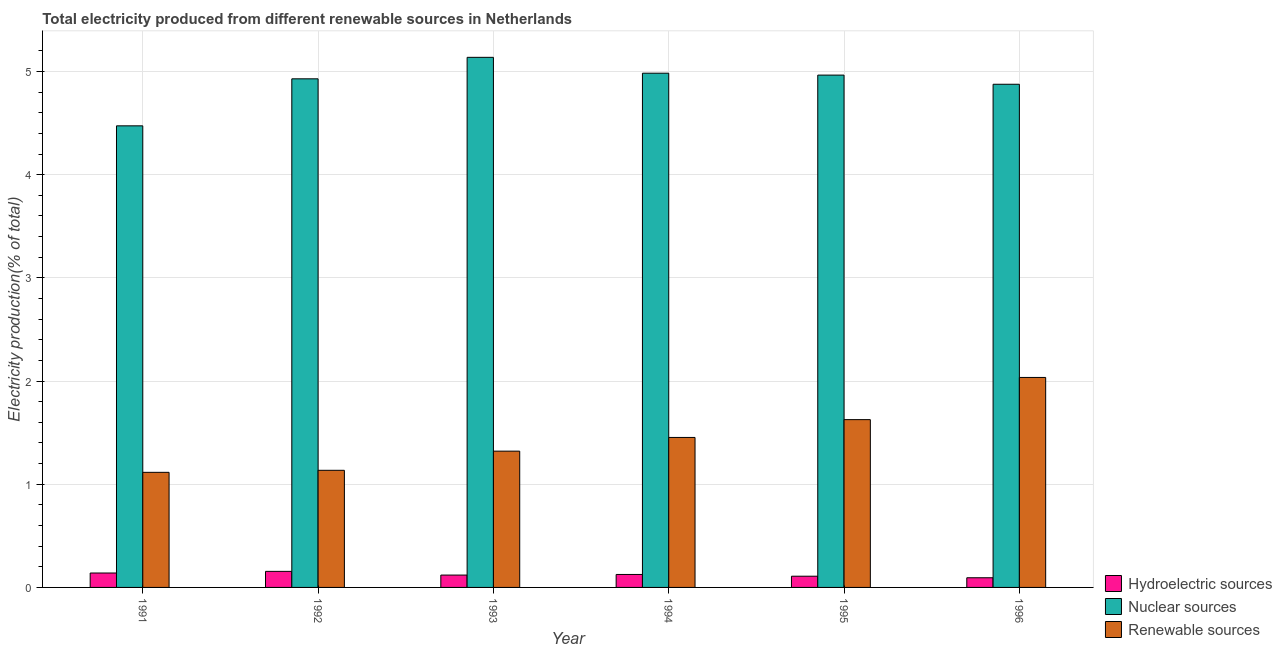How many different coloured bars are there?
Offer a terse response. 3. How many groups of bars are there?
Keep it short and to the point. 6. Are the number of bars per tick equal to the number of legend labels?
Offer a terse response. Yes. How many bars are there on the 4th tick from the left?
Ensure brevity in your answer.  3. What is the percentage of electricity produced by hydroelectric sources in 1995?
Offer a very short reply. 0.11. Across all years, what is the maximum percentage of electricity produced by hydroelectric sources?
Give a very brief answer. 0.16. Across all years, what is the minimum percentage of electricity produced by hydroelectric sources?
Your response must be concise. 0.09. In which year was the percentage of electricity produced by hydroelectric sources minimum?
Make the answer very short. 1996. What is the total percentage of electricity produced by nuclear sources in the graph?
Your response must be concise. 29.36. What is the difference between the percentage of electricity produced by nuclear sources in 1991 and that in 1993?
Provide a short and direct response. -0.66. What is the difference between the percentage of electricity produced by renewable sources in 1991 and the percentage of electricity produced by nuclear sources in 1992?
Offer a very short reply. -0.02. What is the average percentage of electricity produced by hydroelectric sources per year?
Keep it short and to the point. 0.12. What is the ratio of the percentage of electricity produced by renewable sources in 1992 to that in 1995?
Provide a succinct answer. 0.7. Is the percentage of electricity produced by nuclear sources in 1993 less than that in 1996?
Offer a terse response. No. Is the difference between the percentage of electricity produced by nuclear sources in 1994 and 1995 greater than the difference between the percentage of electricity produced by hydroelectric sources in 1994 and 1995?
Give a very brief answer. No. What is the difference between the highest and the second highest percentage of electricity produced by hydroelectric sources?
Offer a very short reply. 0.02. What is the difference between the highest and the lowest percentage of electricity produced by nuclear sources?
Offer a terse response. 0.66. What does the 3rd bar from the left in 1995 represents?
Your answer should be very brief. Renewable sources. What does the 3rd bar from the right in 1994 represents?
Your answer should be compact. Hydroelectric sources. How many bars are there?
Give a very brief answer. 18. Are all the bars in the graph horizontal?
Ensure brevity in your answer.  No. Does the graph contain any zero values?
Give a very brief answer. No. Does the graph contain grids?
Provide a short and direct response. Yes. Where does the legend appear in the graph?
Give a very brief answer. Bottom right. How many legend labels are there?
Your response must be concise. 3. What is the title of the graph?
Offer a very short reply. Total electricity produced from different renewable sources in Netherlands. What is the label or title of the X-axis?
Offer a very short reply. Year. What is the Electricity production(% of total) in Hydroelectric sources in 1991?
Offer a terse response. 0.14. What is the Electricity production(% of total) of Nuclear sources in 1991?
Ensure brevity in your answer.  4.47. What is the Electricity production(% of total) in Renewable sources in 1991?
Give a very brief answer. 1.12. What is the Electricity production(% of total) in Hydroelectric sources in 1992?
Keep it short and to the point. 0.16. What is the Electricity production(% of total) of Nuclear sources in 1992?
Keep it short and to the point. 4.93. What is the Electricity production(% of total) of Renewable sources in 1992?
Your answer should be compact. 1.13. What is the Electricity production(% of total) in Hydroelectric sources in 1993?
Keep it short and to the point. 0.12. What is the Electricity production(% of total) in Nuclear sources in 1993?
Your answer should be compact. 5.14. What is the Electricity production(% of total) in Renewable sources in 1993?
Give a very brief answer. 1.32. What is the Electricity production(% of total) of Hydroelectric sources in 1994?
Your answer should be compact. 0.13. What is the Electricity production(% of total) in Nuclear sources in 1994?
Ensure brevity in your answer.  4.98. What is the Electricity production(% of total) of Renewable sources in 1994?
Make the answer very short. 1.45. What is the Electricity production(% of total) of Hydroelectric sources in 1995?
Offer a terse response. 0.11. What is the Electricity production(% of total) of Nuclear sources in 1995?
Offer a terse response. 4.97. What is the Electricity production(% of total) of Renewable sources in 1995?
Give a very brief answer. 1.63. What is the Electricity production(% of total) in Hydroelectric sources in 1996?
Your answer should be very brief. 0.09. What is the Electricity production(% of total) in Nuclear sources in 1996?
Ensure brevity in your answer.  4.88. What is the Electricity production(% of total) in Renewable sources in 1996?
Ensure brevity in your answer.  2.03. Across all years, what is the maximum Electricity production(% of total) of Hydroelectric sources?
Provide a succinct answer. 0.16. Across all years, what is the maximum Electricity production(% of total) of Nuclear sources?
Your response must be concise. 5.14. Across all years, what is the maximum Electricity production(% of total) of Renewable sources?
Your answer should be compact. 2.03. Across all years, what is the minimum Electricity production(% of total) in Hydroelectric sources?
Provide a succinct answer. 0.09. Across all years, what is the minimum Electricity production(% of total) of Nuclear sources?
Your response must be concise. 4.47. Across all years, what is the minimum Electricity production(% of total) in Renewable sources?
Provide a succinct answer. 1.12. What is the total Electricity production(% of total) in Hydroelectric sources in the graph?
Give a very brief answer. 0.74. What is the total Electricity production(% of total) of Nuclear sources in the graph?
Provide a succinct answer. 29.36. What is the total Electricity production(% of total) of Renewable sources in the graph?
Your answer should be very brief. 8.69. What is the difference between the Electricity production(% of total) of Hydroelectric sources in 1991 and that in 1992?
Your answer should be compact. -0.02. What is the difference between the Electricity production(% of total) in Nuclear sources in 1991 and that in 1992?
Provide a short and direct response. -0.46. What is the difference between the Electricity production(% of total) in Renewable sources in 1991 and that in 1992?
Ensure brevity in your answer.  -0.02. What is the difference between the Electricity production(% of total) of Hydroelectric sources in 1991 and that in 1993?
Make the answer very short. 0.02. What is the difference between the Electricity production(% of total) of Nuclear sources in 1991 and that in 1993?
Give a very brief answer. -0.66. What is the difference between the Electricity production(% of total) in Renewable sources in 1991 and that in 1993?
Your response must be concise. -0.21. What is the difference between the Electricity production(% of total) in Hydroelectric sources in 1991 and that in 1994?
Provide a short and direct response. 0.01. What is the difference between the Electricity production(% of total) in Nuclear sources in 1991 and that in 1994?
Offer a terse response. -0.51. What is the difference between the Electricity production(% of total) of Renewable sources in 1991 and that in 1994?
Your answer should be compact. -0.34. What is the difference between the Electricity production(% of total) in Hydroelectric sources in 1991 and that in 1995?
Offer a very short reply. 0.03. What is the difference between the Electricity production(% of total) in Nuclear sources in 1991 and that in 1995?
Provide a short and direct response. -0.49. What is the difference between the Electricity production(% of total) in Renewable sources in 1991 and that in 1995?
Make the answer very short. -0.51. What is the difference between the Electricity production(% of total) of Hydroelectric sources in 1991 and that in 1996?
Your answer should be compact. 0.05. What is the difference between the Electricity production(% of total) in Nuclear sources in 1991 and that in 1996?
Provide a short and direct response. -0.4. What is the difference between the Electricity production(% of total) of Renewable sources in 1991 and that in 1996?
Provide a succinct answer. -0.92. What is the difference between the Electricity production(% of total) in Hydroelectric sources in 1992 and that in 1993?
Offer a terse response. 0.04. What is the difference between the Electricity production(% of total) of Nuclear sources in 1992 and that in 1993?
Provide a short and direct response. -0.21. What is the difference between the Electricity production(% of total) of Renewable sources in 1992 and that in 1993?
Provide a short and direct response. -0.19. What is the difference between the Electricity production(% of total) in Hydroelectric sources in 1992 and that in 1994?
Ensure brevity in your answer.  0.03. What is the difference between the Electricity production(% of total) of Nuclear sources in 1992 and that in 1994?
Your answer should be very brief. -0.05. What is the difference between the Electricity production(% of total) in Renewable sources in 1992 and that in 1994?
Provide a succinct answer. -0.32. What is the difference between the Electricity production(% of total) of Hydroelectric sources in 1992 and that in 1995?
Provide a succinct answer. 0.05. What is the difference between the Electricity production(% of total) in Nuclear sources in 1992 and that in 1995?
Provide a short and direct response. -0.04. What is the difference between the Electricity production(% of total) in Renewable sources in 1992 and that in 1995?
Provide a short and direct response. -0.49. What is the difference between the Electricity production(% of total) in Hydroelectric sources in 1992 and that in 1996?
Make the answer very short. 0.06. What is the difference between the Electricity production(% of total) of Nuclear sources in 1992 and that in 1996?
Provide a succinct answer. 0.05. What is the difference between the Electricity production(% of total) of Renewable sources in 1992 and that in 1996?
Your response must be concise. -0.9. What is the difference between the Electricity production(% of total) of Hydroelectric sources in 1993 and that in 1994?
Provide a succinct answer. -0.01. What is the difference between the Electricity production(% of total) of Nuclear sources in 1993 and that in 1994?
Provide a succinct answer. 0.15. What is the difference between the Electricity production(% of total) of Renewable sources in 1993 and that in 1994?
Provide a short and direct response. -0.13. What is the difference between the Electricity production(% of total) in Hydroelectric sources in 1993 and that in 1995?
Keep it short and to the point. 0.01. What is the difference between the Electricity production(% of total) in Nuclear sources in 1993 and that in 1995?
Offer a very short reply. 0.17. What is the difference between the Electricity production(% of total) of Renewable sources in 1993 and that in 1995?
Keep it short and to the point. -0.31. What is the difference between the Electricity production(% of total) of Hydroelectric sources in 1993 and that in 1996?
Keep it short and to the point. 0.03. What is the difference between the Electricity production(% of total) in Nuclear sources in 1993 and that in 1996?
Offer a terse response. 0.26. What is the difference between the Electricity production(% of total) of Renewable sources in 1993 and that in 1996?
Keep it short and to the point. -0.71. What is the difference between the Electricity production(% of total) in Hydroelectric sources in 1994 and that in 1995?
Provide a short and direct response. 0.02. What is the difference between the Electricity production(% of total) in Nuclear sources in 1994 and that in 1995?
Keep it short and to the point. 0.02. What is the difference between the Electricity production(% of total) in Renewable sources in 1994 and that in 1995?
Keep it short and to the point. -0.17. What is the difference between the Electricity production(% of total) in Hydroelectric sources in 1994 and that in 1996?
Your response must be concise. 0.03. What is the difference between the Electricity production(% of total) of Nuclear sources in 1994 and that in 1996?
Keep it short and to the point. 0.11. What is the difference between the Electricity production(% of total) in Renewable sources in 1994 and that in 1996?
Keep it short and to the point. -0.58. What is the difference between the Electricity production(% of total) in Hydroelectric sources in 1995 and that in 1996?
Your response must be concise. 0.01. What is the difference between the Electricity production(% of total) of Nuclear sources in 1995 and that in 1996?
Your response must be concise. 0.09. What is the difference between the Electricity production(% of total) of Renewable sources in 1995 and that in 1996?
Your answer should be compact. -0.41. What is the difference between the Electricity production(% of total) of Hydroelectric sources in 1991 and the Electricity production(% of total) of Nuclear sources in 1992?
Make the answer very short. -4.79. What is the difference between the Electricity production(% of total) of Hydroelectric sources in 1991 and the Electricity production(% of total) of Renewable sources in 1992?
Offer a very short reply. -1. What is the difference between the Electricity production(% of total) of Nuclear sources in 1991 and the Electricity production(% of total) of Renewable sources in 1992?
Make the answer very short. 3.34. What is the difference between the Electricity production(% of total) of Hydroelectric sources in 1991 and the Electricity production(% of total) of Nuclear sources in 1993?
Your answer should be very brief. -5. What is the difference between the Electricity production(% of total) of Hydroelectric sources in 1991 and the Electricity production(% of total) of Renewable sources in 1993?
Provide a short and direct response. -1.18. What is the difference between the Electricity production(% of total) in Nuclear sources in 1991 and the Electricity production(% of total) in Renewable sources in 1993?
Offer a terse response. 3.15. What is the difference between the Electricity production(% of total) in Hydroelectric sources in 1991 and the Electricity production(% of total) in Nuclear sources in 1994?
Your response must be concise. -4.84. What is the difference between the Electricity production(% of total) in Hydroelectric sources in 1991 and the Electricity production(% of total) in Renewable sources in 1994?
Ensure brevity in your answer.  -1.31. What is the difference between the Electricity production(% of total) in Nuclear sources in 1991 and the Electricity production(% of total) in Renewable sources in 1994?
Make the answer very short. 3.02. What is the difference between the Electricity production(% of total) in Hydroelectric sources in 1991 and the Electricity production(% of total) in Nuclear sources in 1995?
Keep it short and to the point. -4.83. What is the difference between the Electricity production(% of total) in Hydroelectric sources in 1991 and the Electricity production(% of total) in Renewable sources in 1995?
Make the answer very short. -1.49. What is the difference between the Electricity production(% of total) in Nuclear sources in 1991 and the Electricity production(% of total) in Renewable sources in 1995?
Give a very brief answer. 2.85. What is the difference between the Electricity production(% of total) in Hydroelectric sources in 1991 and the Electricity production(% of total) in Nuclear sources in 1996?
Your response must be concise. -4.74. What is the difference between the Electricity production(% of total) of Hydroelectric sources in 1991 and the Electricity production(% of total) of Renewable sources in 1996?
Make the answer very short. -1.9. What is the difference between the Electricity production(% of total) of Nuclear sources in 1991 and the Electricity production(% of total) of Renewable sources in 1996?
Your answer should be compact. 2.44. What is the difference between the Electricity production(% of total) in Hydroelectric sources in 1992 and the Electricity production(% of total) in Nuclear sources in 1993?
Your answer should be very brief. -4.98. What is the difference between the Electricity production(% of total) in Hydroelectric sources in 1992 and the Electricity production(% of total) in Renewable sources in 1993?
Your answer should be compact. -1.17. What is the difference between the Electricity production(% of total) of Nuclear sources in 1992 and the Electricity production(% of total) of Renewable sources in 1993?
Your response must be concise. 3.61. What is the difference between the Electricity production(% of total) of Hydroelectric sources in 1992 and the Electricity production(% of total) of Nuclear sources in 1994?
Ensure brevity in your answer.  -4.83. What is the difference between the Electricity production(% of total) of Hydroelectric sources in 1992 and the Electricity production(% of total) of Renewable sources in 1994?
Your answer should be very brief. -1.3. What is the difference between the Electricity production(% of total) in Nuclear sources in 1992 and the Electricity production(% of total) in Renewable sources in 1994?
Provide a short and direct response. 3.48. What is the difference between the Electricity production(% of total) in Hydroelectric sources in 1992 and the Electricity production(% of total) in Nuclear sources in 1995?
Make the answer very short. -4.81. What is the difference between the Electricity production(% of total) of Hydroelectric sources in 1992 and the Electricity production(% of total) of Renewable sources in 1995?
Make the answer very short. -1.47. What is the difference between the Electricity production(% of total) of Nuclear sources in 1992 and the Electricity production(% of total) of Renewable sources in 1995?
Offer a terse response. 3.3. What is the difference between the Electricity production(% of total) in Hydroelectric sources in 1992 and the Electricity production(% of total) in Nuclear sources in 1996?
Ensure brevity in your answer.  -4.72. What is the difference between the Electricity production(% of total) in Hydroelectric sources in 1992 and the Electricity production(% of total) in Renewable sources in 1996?
Provide a succinct answer. -1.88. What is the difference between the Electricity production(% of total) in Nuclear sources in 1992 and the Electricity production(% of total) in Renewable sources in 1996?
Make the answer very short. 2.89. What is the difference between the Electricity production(% of total) in Hydroelectric sources in 1993 and the Electricity production(% of total) in Nuclear sources in 1994?
Your answer should be very brief. -4.86. What is the difference between the Electricity production(% of total) in Hydroelectric sources in 1993 and the Electricity production(% of total) in Renewable sources in 1994?
Provide a short and direct response. -1.33. What is the difference between the Electricity production(% of total) in Nuclear sources in 1993 and the Electricity production(% of total) in Renewable sources in 1994?
Ensure brevity in your answer.  3.68. What is the difference between the Electricity production(% of total) in Hydroelectric sources in 1993 and the Electricity production(% of total) in Nuclear sources in 1995?
Offer a very short reply. -4.85. What is the difference between the Electricity production(% of total) in Hydroelectric sources in 1993 and the Electricity production(% of total) in Renewable sources in 1995?
Give a very brief answer. -1.51. What is the difference between the Electricity production(% of total) of Nuclear sources in 1993 and the Electricity production(% of total) of Renewable sources in 1995?
Your answer should be compact. 3.51. What is the difference between the Electricity production(% of total) of Hydroelectric sources in 1993 and the Electricity production(% of total) of Nuclear sources in 1996?
Your response must be concise. -4.76. What is the difference between the Electricity production(% of total) in Hydroelectric sources in 1993 and the Electricity production(% of total) in Renewable sources in 1996?
Your answer should be very brief. -1.92. What is the difference between the Electricity production(% of total) in Nuclear sources in 1993 and the Electricity production(% of total) in Renewable sources in 1996?
Make the answer very short. 3.1. What is the difference between the Electricity production(% of total) in Hydroelectric sources in 1994 and the Electricity production(% of total) in Nuclear sources in 1995?
Ensure brevity in your answer.  -4.84. What is the difference between the Electricity production(% of total) of Hydroelectric sources in 1994 and the Electricity production(% of total) of Renewable sources in 1995?
Give a very brief answer. -1.5. What is the difference between the Electricity production(% of total) in Nuclear sources in 1994 and the Electricity production(% of total) in Renewable sources in 1995?
Keep it short and to the point. 3.36. What is the difference between the Electricity production(% of total) in Hydroelectric sources in 1994 and the Electricity production(% of total) in Nuclear sources in 1996?
Ensure brevity in your answer.  -4.75. What is the difference between the Electricity production(% of total) in Hydroelectric sources in 1994 and the Electricity production(% of total) in Renewable sources in 1996?
Provide a succinct answer. -1.91. What is the difference between the Electricity production(% of total) of Nuclear sources in 1994 and the Electricity production(% of total) of Renewable sources in 1996?
Your answer should be very brief. 2.95. What is the difference between the Electricity production(% of total) of Hydroelectric sources in 1995 and the Electricity production(% of total) of Nuclear sources in 1996?
Provide a short and direct response. -4.77. What is the difference between the Electricity production(% of total) of Hydroelectric sources in 1995 and the Electricity production(% of total) of Renewable sources in 1996?
Your answer should be very brief. -1.93. What is the difference between the Electricity production(% of total) of Nuclear sources in 1995 and the Electricity production(% of total) of Renewable sources in 1996?
Ensure brevity in your answer.  2.93. What is the average Electricity production(% of total) in Hydroelectric sources per year?
Your response must be concise. 0.12. What is the average Electricity production(% of total) of Nuclear sources per year?
Ensure brevity in your answer.  4.89. What is the average Electricity production(% of total) in Renewable sources per year?
Your response must be concise. 1.45. In the year 1991, what is the difference between the Electricity production(% of total) in Hydroelectric sources and Electricity production(% of total) in Nuclear sources?
Your response must be concise. -4.33. In the year 1991, what is the difference between the Electricity production(% of total) of Hydroelectric sources and Electricity production(% of total) of Renewable sources?
Give a very brief answer. -0.98. In the year 1991, what is the difference between the Electricity production(% of total) in Nuclear sources and Electricity production(% of total) in Renewable sources?
Offer a terse response. 3.36. In the year 1992, what is the difference between the Electricity production(% of total) in Hydroelectric sources and Electricity production(% of total) in Nuclear sources?
Your answer should be compact. -4.77. In the year 1992, what is the difference between the Electricity production(% of total) in Hydroelectric sources and Electricity production(% of total) in Renewable sources?
Ensure brevity in your answer.  -0.98. In the year 1992, what is the difference between the Electricity production(% of total) in Nuclear sources and Electricity production(% of total) in Renewable sources?
Keep it short and to the point. 3.79. In the year 1993, what is the difference between the Electricity production(% of total) of Hydroelectric sources and Electricity production(% of total) of Nuclear sources?
Offer a terse response. -5.02. In the year 1993, what is the difference between the Electricity production(% of total) of Hydroelectric sources and Electricity production(% of total) of Renewable sources?
Offer a very short reply. -1.2. In the year 1993, what is the difference between the Electricity production(% of total) of Nuclear sources and Electricity production(% of total) of Renewable sources?
Ensure brevity in your answer.  3.82. In the year 1994, what is the difference between the Electricity production(% of total) of Hydroelectric sources and Electricity production(% of total) of Nuclear sources?
Offer a terse response. -4.86. In the year 1994, what is the difference between the Electricity production(% of total) in Hydroelectric sources and Electricity production(% of total) in Renewable sources?
Your answer should be compact. -1.33. In the year 1994, what is the difference between the Electricity production(% of total) of Nuclear sources and Electricity production(% of total) of Renewable sources?
Keep it short and to the point. 3.53. In the year 1995, what is the difference between the Electricity production(% of total) of Hydroelectric sources and Electricity production(% of total) of Nuclear sources?
Offer a terse response. -4.86. In the year 1995, what is the difference between the Electricity production(% of total) in Hydroelectric sources and Electricity production(% of total) in Renewable sources?
Ensure brevity in your answer.  -1.52. In the year 1995, what is the difference between the Electricity production(% of total) of Nuclear sources and Electricity production(% of total) of Renewable sources?
Keep it short and to the point. 3.34. In the year 1996, what is the difference between the Electricity production(% of total) in Hydroelectric sources and Electricity production(% of total) in Nuclear sources?
Provide a succinct answer. -4.78. In the year 1996, what is the difference between the Electricity production(% of total) of Hydroelectric sources and Electricity production(% of total) of Renewable sources?
Your answer should be very brief. -1.94. In the year 1996, what is the difference between the Electricity production(% of total) of Nuclear sources and Electricity production(% of total) of Renewable sources?
Offer a terse response. 2.84. What is the ratio of the Electricity production(% of total) in Hydroelectric sources in 1991 to that in 1992?
Offer a terse response. 0.9. What is the ratio of the Electricity production(% of total) in Nuclear sources in 1991 to that in 1992?
Make the answer very short. 0.91. What is the ratio of the Electricity production(% of total) in Renewable sources in 1991 to that in 1992?
Ensure brevity in your answer.  0.98. What is the ratio of the Electricity production(% of total) in Hydroelectric sources in 1991 to that in 1993?
Offer a terse response. 1.17. What is the ratio of the Electricity production(% of total) of Nuclear sources in 1991 to that in 1993?
Keep it short and to the point. 0.87. What is the ratio of the Electricity production(% of total) in Renewable sources in 1991 to that in 1993?
Your response must be concise. 0.84. What is the ratio of the Electricity production(% of total) in Hydroelectric sources in 1991 to that in 1994?
Make the answer very short. 1.11. What is the ratio of the Electricity production(% of total) in Nuclear sources in 1991 to that in 1994?
Keep it short and to the point. 0.9. What is the ratio of the Electricity production(% of total) in Renewable sources in 1991 to that in 1994?
Ensure brevity in your answer.  0.77. What is the ratio of the Electricity production(% of total) in Hydroelectric sources in 1991 to that in 1995?
Ensure brevity in your answer.  1.29. What is the ratio of the Electricity production(% of total) of Nuclear sources in 1991 to that in 1995?
Your answer should be compact. 0.9. What is the ratio of the Electricity production(% of total) of Renewable sources in 1991 to that in 1995?
Your answer should be very brief. 0.69. What is the ratio of the Electricity production(% of total) of Hydroelectric sources in 1991 to that in 1996?
Your answer should be very brief. 1.49. What is the ratio of the Electricity production(% of total) in Nuclear sources in 1991 to that in 1996?
Your response must be concise. 0.92. What is the ratio of the Electricity production(% of total) in Renewable sources in 1991 to that in 1996?
Ensure brevity in your answer.  0.55. What is the ratio of the Electricity production(% of total) in Hydroelectric sources in 1992 to that in 1993?
Ensure brevity in your answer.  1.3. What is the ratio of the Electricity production(% of total) of Nuclear sources in 1992 to that in 1993?
Ensure brevity in your answer.  0.96. What is the ratio of the Electricity production(% of total) in Renewable sources in 1992 to that in 1993?
Keep it short and to the point. 0.86. What is the ratio of the Electricity production(% of total) in Hydroelectric sources in 1992 to that in 1994?
Provide a succinct answer. 1.24. What is the ratio of the Electricity production(% of total) in Nuclear sources in 1992 to that in 1994?
Make the answer very short. 0.99. What is the ratio of the Electricity production(% of total) in Renewable sources in 1992 to that in 1994?
Ensure brevity in your answer.  0.78. What is the ratio of the Electricity production(% of total) of Hydroelectric sources in 1992 to that in 1995?
Provide a succinct answer. 1.43. What is the ratio of the Electricity production(% of total) of Renewable sources in 1992 to that in 1995?
Your answer should be compact. 0.7. What is the ratio of the Electricity production(% of total) in Hydroelectric sources in 1992 to that in 1996?
Give a very brief answer. 1.66. What is the ratio of the Electricity production(% of total) in Nuclear sources in 1992 to that in 1996?
Make the answer very short. 1.01. What is the ratio of the Electricity production(% of total) in Renewable sources in 1992 to that in 1996?
Provide a short and direct response. 0.56. What is the ratio of the Electricity production(% of total) of Hydroelectric sources in 1993 to that in 1994?
Give a very brief answer. 0.95. What is the ratio of the Electricity production(% of total) in Nuclear sources in 1993 to that in 1994?
Offer a very short reply. 1.03. What is the ratio of the Electricity production(% of total) of Renewable sources in 1993 to that in 1994?
Your response must be concise. 0.91. What is the ratio of the Electricity production(% of total) in Hydroelectric sources in 1993 to that in 1995?
Your response must be concise. 1.1. What is the ratio of the Electricity production(% of total) of Nuclear sources in 1993 to that in 1995?
Your answer should be very brief. 1.03. What is the ratio of the Electricity production(% of total) of Renewable sources in 1993 to that in 1995?
Give a very brief answer. 0.81. What is the ratio of the Electricity production(% of total) in Hydroelectric sources in 1993 to that in 1996?
Offer a very short reply. 1.28. What is the ratio of the Electricity production(% of total) in Nuclear sources in 1993 to that in 1996?
Give a very brief answer. 1.05. What is the ratio of the Electricity production(% of total) in Renewable sources in 1993 to that in 1996?
Keep it short and to the point. 0.65. What is the ratio of the Electricity production(% of total) of Hydroelectric sources in 1994 to that in 1995?
Provide a succinct answer. 1.16. What is the ratio of the Electricity production(% of total) in Renewable sources in 1994 to that in 1995?
Make the answer very short. 0.89. What is the ratio of the Electricity production(% of total) in Hydroelectric sources in 1994 to that in 1996?
Your answer should be very brief. 1.34. What is the ratio of the Electricity production(% of total) of Hydroelectric sources in 1995 to that in 1996?
Give a very brief answer. 1.16. What is the ratio of the Electricity production(% of total) in Nuclear sources in 1995 to that in 1996?
Your answer should be compact. 1.02. What is the ratio of the Electricity production(% of total) of Renewable sources in 1995 to that in 1996?
Ensure brevity in your answer.  0.8. What is the difference between the highest and the second highest Electricity production(% of total) of Hydroelectric sources?
Give a very brief answer. 0.02. What is the difference between the highest and the second highest Electricity production(% of total) of Nuclear sources?
Provide a short and direct response. 0.15. What is the difference between the highest and the second highest Electricity production(% of total) of Renewable sources?
Make the answer very short. 0.41. What is the difference between the highest and the lowest Electricity production(% of total) of Hydroelectric sources?
Keep it short and to the point. 0.06. What is the difference between the highest and the lowest Electricity production(% of total) in Nuclear sources?
Make the answer very short. 0.66. What is the difference between the highest and the lowest Electricity production(% of total) of Renewable sources?
Offer a very short reply. 0.92. 